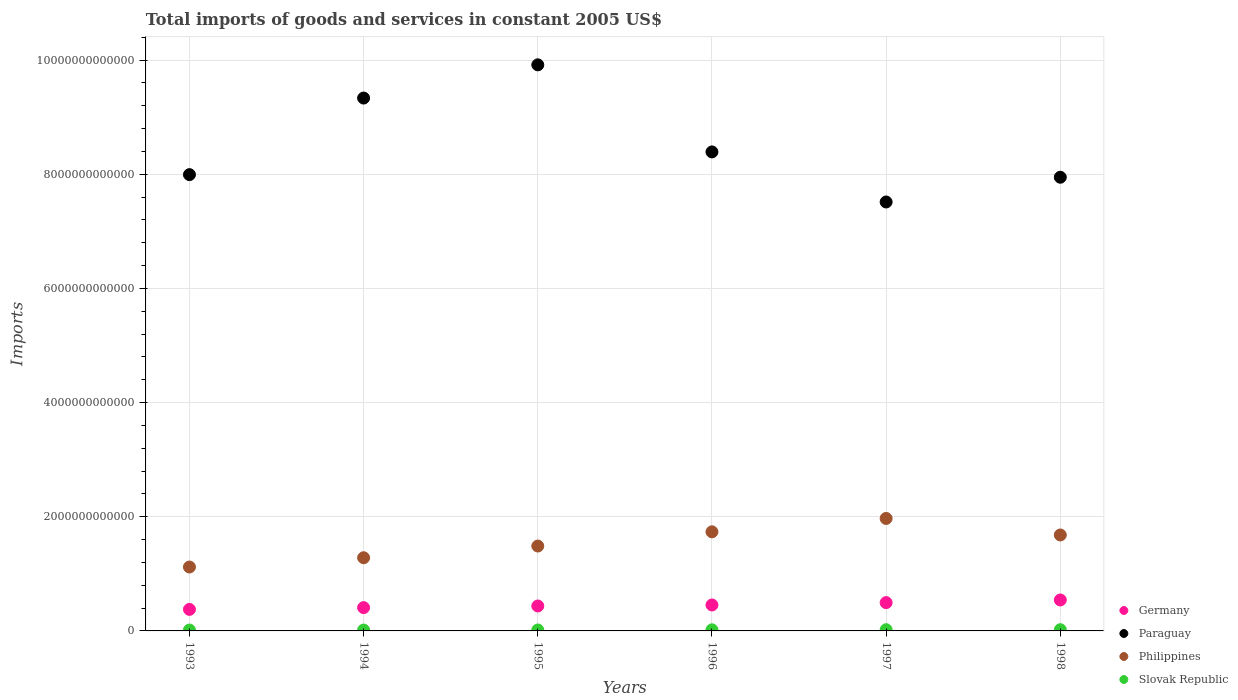How many different coloured dotlines are there?
Offer a terse response. 4. What is the total imports of goods and services in Paraguay in 1994?
Provide a succinct answer. 9.33e+12. Across all years, what is the maximum total imports of goods and services in Philippines?
Give a very brief answer. 1.97e+12. Across all years, what is the minimum total imports of goods and services in Slovak Republic?
Your answer should be compact. 1.49e+1. In which year was the total imports of goods and services in Slovak Republic minimum?
Make the answer very short. 1994. What is the total total imports of goods and services in Philippines in the graph?
Keep it short and to the point. 9.27e+12. What is the difference between the total imports of goods and services in Slovak Republic in 1996 and that in 1998?
Make the answer very short. -1.74e+09. What is the difference between the total imports of goods and services in Paraguay in 1993 and the total imports of goods and services in Slovak Republic in 1997?
Your answer should be compact. 7.97e+12. What is the average total imports of goods and services in Paraguay per year?
Your response must be concise. 8.52e+12. In the year 1995, what is the difference between the total imports of goods and services in Philippines and total imports of goods and services in Paraguay?
Give a very brief answer. -8.43e+12. In how many years, is the total imports of goods and services in Slovak Republic greater than 800000000000 US$?
Give a very brief answer. 0. What is the ratio of the total imports of goods and services in Germany in 1996 to that in 1998?
Ensure brevity in your answer.  0.84. Is the difference between the total imports of goods and services in Philippines in 1995 and 1997 greater than the difference between the total imports of goods and services in Paraguay in 1995 and 1997?
Keep it short and to the point. No. What is the difference between the highest and the second highest total imports of goods and services in Slovak Republic?
Your answer should be compact. 2.36e+08. What is the difference between the highest and the lowest total imports of goods and services in Slovak Republic?
Offer a terse response. 6.63e+09. Is it the case that in every year, the sum of the total imports of goods and services in Germany and total imports of goods and services in Slovak Republic  is greater than the total imports of goods and services in Philippines?
Make the answer very short. No. What is the difference between two consecutive major ticks on the Y-axis?
Your answer should be compact. 2.00e+12. Does the graph contain any zero values?
Make the answer very short. No. Does the graph contain grids?
Give a very brief answer. Yes. Where does the legend appear in the graph?
Provide a succinct answer. Bottom right. What is the title of the graph?
Make the answer very short. Total imports of goods and services in constant 2005 US$. What is the label or title of the X-axis?
Offer a terse response. Years. What is the label or title of the Y-axis?
Offer a terse response. Imports. What is the Imports of Germany in 1993?
Provide a short and direct response. 3.77e+11. What is the Imports of Paraguay in 1993?
Make the answer very short. 7.99e+12. What is the Imports of Philippines in 1993?
Your answer should be very brief. 1.12e+12. What is the Imports of Slovak Republic in 1993?
Your answer should be compact. 1.56e+1. What is the Imports in Germany in 1994?
Make the answer very short. 4.08e+11. What is the Imports in Paraguay in 1994?
Provide a succinct answer. 9.33e+12. What is the Imports in Philippines in 1994?
Provide a succinct answer. 1.28e+12. What is the Imports in Slovak Republic in 1994?
Provide a short and direct response. 1.49e+1. What is the Imports in Germany in 1995?
Provide a short and direct response. 4.37e+11. What is the Imports of Paraguay in 1995?
Offer a terse response. 9.92e+12. What is the Imports in Philippines in 1995?
Your answer should be very brief. 1.49e+12. What is the Imports of Slovak Republic in 1995?
Give a very brief answer. 1.66e+1. What is the Imports of Germany in 1996?
Keep it short and to the point. 4.54e+11. What is the Imports in Paraguay in 1996?
Your answer should be compact. 8.39e+12. What is the Imports in Philippines in 1996?
Provide a short and direct response. 1.74e+12. What is the Imports of Slovak Republic in 1996?
Your answer should be compact. 1.95e+1. What is the Imports in Germany in 1997?
Your answer should be compact. 4.96e+11. What is the Imports of Paraguay in 1997?
Your response must be concise. 7.51e+12. What is the Imports in Philippines in 1997?
Keep it short and to the point. 1.97e+12. What is the Imports of Slovak Republic in 1997?
Make the answer very short. 2.15e+1. What is the Imports in Germany in 1998?
Offer a very short reply. 5.42e+11. What is the Imports of Paraguay in 1998?
Your answer should be very brief. 7.95e+12. What is the Imports in Philippines in 1998?
Your answer should be compact. 1.68e+12. What is the Imports of Slovak Republic in 1998?
Give a very brief answer. 2.13e+1. Across all years, what is the maximum Imports in Germany?
Offer a terse response. 5.42e+11. Across all years, what is the maximum Imports of Paraguay?
Keep it short and to the point. 9.92e+12. Across all years, what is the maximum Imports in Philippines?
Provide a succinct answer. 1.97e+12. Across all years, what is the maximum Imports in Slovak Republic?
Your response must be concise. 2.15e+1. Across all years, what is the minimum Imports in Germany?
Give a very brief answer. 3.77e+11. Across all years, what is the minimum Imports of Paraguay?
Keep it short and to the point. 7.51e+12. Across all years, what is the minimum Imports in Philippines?
Ensure brevity in your answer.  1.12e+12. Across all years, what is the minimum Imports of Slovak Republic?
Your response must be concise. 1.49e+1. What is the total Imports in Germany in the graph?
Make the answer very short. 2.71e+12. What is the total Imports in Paraguay in the graph?
Your response must be concise. 5.11e+13. What is the total Imports in Philippines in the graph?
Provide a short and direct response. 9.27e+12. What is the total Imports of Slovak Republic in the graph?
Your answer should be compact. 1.09e+11. What is the difference between the Imports in Germany in 1993 and that in 1994?
Ensure brevity in your answer.  -3.10e+1. What is the difference between the Imports of Paraguay in 1993 and that in 1994?
Offer a terse response. -1.34e+12. What is the difference between the Imports of Philippines in 1993 and that in 1994?
Your answer should be very brief. -1.62e+11. What is the difference between the Imports in Slovak Republic in 1993 and that in 1994?
Ensure brevity in your answer.  7.39e+08. What is the difference between the Imports in Germany in 1993 and that in 1995?
Your answer should be compact. -5.98e+1. What is the difference between the Imports in Paraguay in 1993 and that in 1995?
Offer a very short reply. -1.92e+12. What is the difference between the Imports in Philippines in 1993 and that in 1995?
Ensure brevity in your answer.  -3.68e+11. What is the difference between the Imports of Slovak Republic in 1993 and that in 1995?
Provide a short and direct response. -9.92e+08. What is the difference between the Imports in Germany in 1993 and that in 1996?
Offer a very short reply. -7.74e+1. What is the difference between the Imports of Paraguay in 1993 and that in 1996?
Provide a short and direct response. -3.98e+11. What is the difference between the Imports of Philippines in 1993 and that in 1996?
Your answer should be compact. -6.17e+11. What is the difference between the Imports of Slovak Republic in 1993 and that in 1996?
Offer a very short reply. -3.91e+09. What is the difference between the Imports of Germany in 1993 and that in 1997?
Provide a succinct answer. -1.19e+11. What is the difference between the Imports in Paraguay in 1993 and that in 1997?
Your answer should be compact. 4.79e+11. What is the difference between the Imports in Philippines in 1993 and that in 1997?
Make the answer very short. -8.51e+11. What is the difference between the Imports in Slovak Republic in 1993 and that in 1997?
Your answer should be compact. -5.89e+09. What is the difference between the Imports in Germany in 1993 and that in 1998?
Your answer should be compact. -1.65e+11. What is the difference between the Imports of Paraguay in 1993 and that in 1998?
Your answer should be very brief. 4.57e+1. What is the difference between the Imports in Philippines in 1993 and that in 1998?
Ensure brevity in your answer.  -5.61e+11. What is the difference between the Imports in Slovak Republic in 1993 and that in 1998?
Your response must be concise. -5.65e+09. What is the difference between the Imports of Germany in 1994 and that in 1995?
Ensure brevity in your answer.  -2.89e+1. What is the difference between the Imports of Paraguay in 1994 and that in 1995?
Your response must be concise. -5.82e+11. What is the difference between the Imports of Philippines in 1994 and that in 1995?
Your answer should be compact. -2.05e+11. What is the difference between the Imports of Slovak Republic in 1994 and that in 1995?
Your answer should be compact. -1.73e+09. What is the difference between the Imports of Germany in 1994 and that in 1996?
Keep it short and to the point. -4.65e+1. What is the difference between the Imports in Paraguay in 1994 and that in 1996?
Make the answer very short. 9.44e+11. What is the difference between the Imports of Philippines in 1994 and that in 1996?
Your response must be concise. -4.54e+11. What is the difference between the Imports of Slovak Republic in 1994 and that in 1996?
Offer a terse response. -4.65e+09. What is the difference between the Imports in Germany in 1994 and that in 1997?
Your answer should be compact. -8.78e+1. What is the difference between the Imports in Paraguay in 1994 and that in 1997?
Your answer should be compact. 1.82e+12. What is the difference between the Imports of Philippines in 1994 and that in 1997?
Make the answer very short. -6.88e+11. What is the difference between the Imports of Slovak Republic in 1994 and that in 1997?
Keep it short and to the point. -6.63e+09. What is the difference between the Imports of Germany in 1994 and that in 1998?
Provide a succinct answer. -1.34e+11. What is the difference between the Imports in Paraguay in 1994 and that in 1998?
Give a very brief answer. 1.39e+12. What is the difference between the Imports in Philippines in 1994 and that in 1998?
Provide a succinct answer. -3.99e+11. What is the difference between the Imports of Slovak Republic in 1994 and that in 1998?
Provide a succinct answer. -6.39e+09. What is the difference between the Imports in Germany in 1995 and that in 1996?
Your response must be concise. -1.76e+1. What is the difference between the Imports in Paraguay in 1995 and that in 1996?
Your answer should be compact. 1.53e+12. What is the difference between the Imports in Philippines in 1995 and that in 1996?
Provide a succinct answer. -2.49e+11. What is the difference between the Imports in Slovak Republic in 1995 and that in 1996?
Your answer should be very brief. -2.92e+09. What is the difference between the Imports in Germany in 1995 and that in 1997?
Your answer should be very brief. -5.89e+1. What is the difference between the Imports in Paraguay in 1995 and that in 1997?
Offer a terse response. 2.40e+12. What is the difference between the Imports of Philippines in 1995 and that in 1997?
Give a very brief answer. -4.83e+11. What is the difference between the Imports of Slovak Republic in 1995 and that in 1997?
Provide a short and direct response. -4.90e+09. What is the difference between the Imports in Germany in 1995 and that in 1998?
Keep it short and to the point. -1.05e+11. What is the difference between the Imports of Paraguay in 1995 and that in 1998?
Provide a succinct answer. 1.97e+12. What is the difference between the Imports of Philippines in 1995 and that in 1998?
Keep it short and to the point. -1.94e+11. What is the difference between the Imports of Slovak Republic in 1995 and that in 1998?
Your response must be concise. -4.66e+09. What is the difference between the Imports in Germany in 1996 and that in 1997?
Make the answer very short. -4.13e+1. What is the difference between the Imports of Paraguay in 1996 and that in 1997?
Offer a terse response. 8.77e+11. What is the difference between the Imports in Philippines in 1996 and that in 1997?
Provide a short and direct response. -2.34e+11. What is the difference between the Imports of Slovak Republic in 1996 and that in 1997?
Your answer should be very brief. -1.98e+09. What is the difference between the Imports in Germany in 1996 and that in 1998?
Ensure brevity in your answer.  -8.78e+1. What is the difference between the Imports of Paraguay in 1996 and that in 1998?
Ensure brevity in your answer.  4.44e+11. What is the difference between the Imports in Philippines in 1996 and that in 1998?
Offer a terse response. 5.54e+1. What is the difference between the Imports in Slovak Republic in 1996 and that in 1998?
Your answer should be compact. -1.74e+09. What is the difference between the Imports in Germany in 1997 and that in 1998?
Make the answer very short. -4.65e+1. What is the difference between the Imports of Paraguay in 1997 and that in 1998?
Offer a very short reply. -4.33e+11. What is the difference between the Imports in Philippines in 1997 and that in 1998?
Provide a short and direct response. 2.90e+11. What is the difference between the Imports in Slovak Republic in 1997 and that in 1998?
Your answer should be very brief. 2.36e+08. What is the difference between the Imports in Germany in 1993 and the Imports in Paraguay in 1994?
Ensure brevity in your answer.  -8.96e+12. What is the difference between the Imports in Germany in 1993 and the Imports in Philippines in 1994?
Offer a very short reply. -9.05e+11. What is the difference between the Imports in Germany in 1993 and the Imports in Slovak Republic in 1994?
Ensure brevity in your answer.  3.62e+11. What is the difference between the Imports of Paraguay in 1993 and the Imports of Philippines in 1994?
Your response must be concise. 6.71e+12. What is the difference between the Imports in Paraguay in 1993 and the Imports in Slovak Republic in 1994?
Provide a short and direct response. 7.98e+12. What is the difference between the Imports in Philippines in 1993 and the Imports in Slovak Republic in 1994?
Make the answer very short. 1.10e+12. What is the difference between the Imports of Germany in 1993 and the Imports of Paraguay in 1995?
Give a very brief answer. -9.54e+12. What is the difference between the Imports in Germany in 1993 and the Imports in Philippines in 1995?
Offer a terse response. -1.11e+12. What is the difference between the Imports in Germany in 1993 and the Imports in Slovak Republic in 1995?
Your answer should be compact. 3.60e+11. What is the difference between the Imports in Paraguay in 1993 and the Imports in Philippines in 1995?
Your response must be concise. 6.51e+12. What is the difference between the Imports in Paraguay in 1993 and the Imports in Slovak Republic in 1995?
Give a very brief answer. 7.98e+12. What is the difference between the Imports in Philippines in 1993 and the Imports in Slovak Republic in 1995?
Give a very brief answer. 1.10e+12. What is the difference between the Imports of Germany in 1993 and the Imports of Paraguay in 1996?
Offer a very short reply. -8.01e+12. What is the difference between the Imports of Germany in 1993 and the Imports of Philippines in 1996?
Provide a short and direct response. -1.36e+12. What is the difference between the Imports of Germany in 1993 and the Imports of Slovak Republic in 1996?
Give a very brief answer. 3.58e+11. What is the difference between the Imports in Paraguay in 1993 and the Imports in Philippines in 1996?
Make the answer very short. 6.26e+12. What is the difference between the Imports in Paraguay in 1993 and the Imports in Slovak Republic in 1996?
Offer a terse response. 7.97e+12. What is the difference between the Imports in Philippines in 1993 and the Imports in Slovak Republic in 1996?
Keep it short and to the point. 1.10e+12. What is the difference between the Imports in Germany in 1993 and the Imports in Paraguay in 1997?
Offer a terse response. -7.14e+12. What is the difference between the Imports of Germany in 1993 and the Imports of Philippines in 1997?
Offer a very short reply. -1.59e+12. What is the difference between the Imports of Germany in 1993 and the Imports of Slovak Republic in 1997?
Provide a short and direct response. 3.56e+11. What is the difference between the Imports of Paraguay in 1993 and the Imports of Philippines in 1997?
Ensure brevity in your answer.  6.02e+12. What is the difference between the Imports in Paraguay in 1993 and the Imports in Slovak Republic in 1997?
Your answer should be very brief. 7.97e+12. What is the difference between the Imports of Philippines in 1993 and the Imports of Slovak Republic in 1997?
Offer a terse response. 1.10e+12. What is the difference between the Imports in Germany in 1993 and the Imports in Paraguay in 1998?
Your response must be concise. -7.57e+12. What is the difference between the Imports in Germany in 1993 and the Imports in Philippines in 1998?
Keep it short and to the point. -1.30e+12. What is the difference between the Imports of Germany in 1993 and the Imports of Slovak Republic in 1998?
Keep it short and to the point. 3.56e+11. What is the difference between the Imports in Paraguay in 1993 and the Imports in Philippines in 1998?
Offer a very short reply. 6.31e+12. What is the difference between the Imports of Paraguay in 1993 and the Imports of Slovak Republic in 1998?
Your response must be concise. 7.97e+12. What is the difference between the Imports in Philippines in 1993 and the Imports in Slovak Republic in 1998?
Keep it short and to the point. 1.10e+12. What is the difference between the Imports of Germany in 1994 and the Imports of Paraguay in 1995?
Keep it short and to the point. -9.51e+12. What is the difference between the Imports in Germany in 1994 and the Imports in Philippines in 1995?
Make the answer very short. -1.08e+12. What is the difference between the Imports of Germany in 1994 and the Imports of Slovak Republic in 1995?
Ensure brevity in your answer.  3.91e+11. What is the difference between the Imports of Paraguay in 1994 and the Imports of Philippines in 1995?
Offer a very short reply. 7.85e+12. What is the difference between the Imports of Paraguay in 1994 and the Imports of Slovak Republic in 1995?
Make the answer very short. 9.32e+12. What is the difference between the Imports of Philippines in 1994 and the Imports of Slovak Republic in 1995?
Your answer should be compact. 1.27e+12. What is the difference between the Imports in Germany in 1994 and the Imports in Paraguay in 1996?
Offer a terse response. -7.98e+12. What is the difference between the Imports of Germany in 1994 and the Imports of Philippines in 1996?
Ensure brevity in your answer.  -1.33e+12. What is the difference between the Imports in Germany in 1994 and the Imports in Slovak Republic in 1996?
Provide a short and direct response. 3.88e+11. What is the difference between the Imports in Paraguay in 1994 and the Imports in Philippines in 1996?
Keep it short and to the point. 7.60e+12. What is the difference between the Imports in Paraguay in 1994 and the Imports in Slovak Republic in 1996?
Provide a short and direct response. 9.31e+12. What is the difference between the Imports in Philippines in 1994 and the Imports in Slovak Republic in 1996?
Offer a terse response. 1.26e+12. What is the difference between the Imports in Germany in 1994 and the Imports in Paraguay in 1997?
Keep it short and to the point. -7.11e+12. What is the difference between the Imports in Germany in 1994 and the Imports in Philippines in 1997?
Give a very brief answer. -1.56e+12. What is the difference between the Imports of Germany in 1994 and the Imports of Slovak Republic in 1997?
Offer a terse response. 3.87e+11. What is the difference between the Imports of Paraguay in 1994 and the Imports of Philippines in 1997?
Your response must be concise. 7.36e+12. What is the difference between the Imports in Paraguay in 1994 and the Imports in Slovak Republic in 1997?
Keep it short and to the point. 9.31e+12. What is the difference between the Imports of Philippines in 1994 and the Imports of Slovak Republic in 1997?
Give a very brief answer. 1.26e+12. What is the difference between the Imports in Germany in 1994 and the Imports in Paraguay in 1998?
Ensure brevity in your answer.  -7.54e+12. What is the difference between the Imports of Germany in 1994 and the Imports of Philippines in 1998?
Ensure brevity in your answer.  -1.27e+12. What is the difference between the Imports of Germany in 1994 and the Imports of Slovak Republic in 1998?
Keep it short and to the point. 3.87e+11. What is the difference between the Imports in Paraguay in 1994 and the Imports in Philippines in 1998?
Your answer should be compact. 7.65e+12. What is the difference between the Imports of Paraguay in 1994 and the Imports of Slovak Republic in 1998?
Offer a very short reply. 9.31e+12. What is the difference between the Imports in Philippines in 1994 and the Imports in Slovak Republic in 1998?
Keep it short and to the point. 1.26e+12. What is the difference between the Imports of Germany in 1995 and the Imports of Paraguay in 1996?
Your answer should be compact. -7.95e+12. What is the difference between the Imports of Germany in 1995 and the Imports of Philippines in 1996?
Your answer should be compact. -1.30e+12. What is the difference between the Imports of Germany in 1995 and the Imports of Slovak Republic in 1996?
Provide a short and direct response. 4.17e+11. What is the difference between the Imports in Paraguay in 1995 and the Imports in Philippines in 1996?
Offer a very short reply. 8.18e+12. What is the difference between the Imports in Paraguay in 1995 and the Imports in Slovak Republic in 1996?
Your answer should be compact. 9.90e+12. What is the difference between the Imports in Philippines in 1995 and the Imports in Slovak Republic in 1996?
Your answer should be compact. 1.47e+12. What is the difference between the Imports of Germany in 1995 and the Imports of Paraguay in 1997?
Make the answer very short. -7.08e+12. What is the difference between the Imports of Germany in 1995 and the Imports of Philippines in 1997?
Provide a succinct answer. -1.53e+12. What is the difference between the Imports in Germany in 1995 and the Imports in Slovak Republic in 1997?
Offer a very short reply. 4.15e+11. What is the difference between the Imports of Paraguay in 1995 and the Imports of Philippines in 1997?
Keep it short and to the point. 7.95e+12. What is the difference between the Imports of Paraguay in 1995 and the Imports of Slovak Republic in 1997?
Your answer should be very brief. 9.89e+12. What is the difference between the Imports in Philippines in 1995 and the Imports in Slovak Republic in 1997?
Keep it short and to the point. 1.47e+12. What is the difference between the Imports in Germany in 1995 and the Imports in Paraguay in 1998?
Offer a very short reply. -7.51e+12. What is the difference between the Imports in Germany in 1995 and the Imports in Philippines in 1998?
Provide a succinct answer. -1.24e+12. What is the difference between the Imports in Germany in 1995 and the Imports in Slovak Republic in 1998?
Your response must be concise. 4.16e+11. What is the difference between the Imports in Paraguay in 1995 and the Imports in Philippines in 1998?
Your answer should be very brief. 8.24e+12. What is the difference between the Imports in Paraguay in 1995 and the Imports in Slovak Republic in 1998?
Your answer should be very brief. 9.89e+12. What is the difference between the Imports in Philippines in 1995 and the Imports in Slovak Republic in 1998?
Ensure brevity in your answer.  1.47e+12. What is the difference between the Imports in Germany in 1996 and the Imports in Paraguay in 1997?
Provide a short and direct response. -7.06e+12. What is the difference between the Imports in Germany in 1996 and the Imports in Philippines in 1997?
Offer a very short reply. -1.52e+12. What is the difference between the Imports of Germany in 1996 and the Imports of Slovak Republic in 1997?
Provide a short and direct response. 4.33e+11. What is the difference between the Imports of Paraguay in 1996 and the Imports of Philippines in 1997?
Your answer should be very brief. 6.42e+12. What is the difference between the Imports of Paraguay in 1996 and the Imports of Slovak Republic in 1997?
Your answer should be very brief. 8.37e+12. What is the difference between the Imports in Philippines in 1996 and the Imports in Slovak Republic in 1997?
Provide a short and direct response. 1.71e+12. What is the difference between the Imports of Germany in 1996 and the Imports of Paraguay in 1998?
Provide a short and direct response. -7.49e+12. What is the difference between the Imports of Germany in 1996 and the Imports of Philippines in 1998?
Offer a terse response. -1.23e+12. What is the difference between the Imports of Germany in 1996 and the Imports of Slovak Republic in 1998?
Provide a succinct answer. 4.33e+11. What is the difference between the Imports of Paraguay in 1996 and the Imports of Philippines in 1998?
Your answer should be very brief. 6.71e+12. What is the difference between the Imports of Paraguay in 1996 and the Imports of Slovak Republic in 1998?
Keep it short and to the point. 8.37e+12. What is the difference between the Imports in Philippines in 1996 and the Imports in Slovak Republic in 1998?
Keep it short and to the point. 1.71e+12. What is the difference between the Imports of Germany in 1997 and the Imports of Paraguay in 1998?
Offer a terse response. -7.45e+12. What is the difference between the Imports in Germany in 1997 and the Imports in Philippines in 1998?
Keep it short and to the point. -1.18e+12. What is the difference between the Imports of Germany in 1997 and the Imports of Slovak Republic in 1998?
Keep it short and to the point. 4.75e+11. What is the difference between the Imports in Paraguay in 1997 and the Imports in Philippines in 1998?
Your answer should be very brief. 5.83e+12. What is the difference between the Imports in Paraguay in 1997 and the Imports in Slovak Republic in 1998?
Provide a short and direct response. 7.49e+12. What is the difference between the Imports in Philippines in 1997 and the Imports in Slovak Republic in 1998?
Make the answer very short. 1.95e+12. What is the average Imports in Germany per year?
Keep it short and to the point. 4.52e+11. What is the average Imports in Paraguay per year?
Offer a terse response. 8.52e+12. What is the average Imports of Philippines per year?
Keep it short and to the point. 1.55e+12. What is the average Imports of Slovak Republic per year?
Provide a short and direct response. 1.82e+1. In the year 1993, what is the difference between the Imports in Germany and Imports in Paraguay?
Offer a terse response. -7.62e+12. In the year 1993, what is the difference between the Imports in Germany and Imports in Philippines?
Offer a terse response. -7.42e+11. In the year 1993, what is the difference between the Imports of Germany and Imports of Slovak Republic?
Your answer should be compact. 3.61e+11. In the year 1993, what is the difference between the Imports of Paraguay and Imports of Philippines?
Provide a short and direct response. 6.87e+12. In the year 1993, what is the difference between the Imports of Paraguay and Imports of Slovak Republic?
Keep it short and to the point. 7.98e+12. In the year 1993, what is the difference between the Imports of Philippines and Imports of Slovak Republic?
Keep it short and to the point. 1.10e+12. In the year 1994, what is the difference between the Imports in Germany and Imports in Paraguay?
Offer a very short reply. -8.93e+12. In the year 1994, what is the difference between the Imports of Germany and Imports of Philippines?
Keep it short and to the point. -8.74e+11. In the year 1994, what is the difference between the Imports in Germany and Imports in Slovak Republic?
Offer a terse response. 3.93e+11. In the year 1994, what is the difference between the Imports of Paraguay and Imports of Philippines?
Your response must be concise. 8.05e+12. In the year 1994, what is the difference between the Imports in Paraguay and Imports in Slovak Republic?
Provide a succinct answer. 9.32e+12. In the year 1994, what is the difference between the Imports of Philippines and Imports of Slovak Republic?
Your answer should be compact. 1.27e+12. In the year 1995, what is the difference between the Imports in Germany and Imports in Paraguay?
Your answer should be very brief. -9.48e+12. In the year 1995, what is the difference between the Imports in Germany and Imports in Philippines?
Your answer should be very brief. -1.05e+12. In the year 1995, what is the difference between the Imports in Germany and Imports in Slovak Republic?
Keep it short and to the point. 4.20e+11. In the year 1995, what is the difference between the Imports in Paraguay and Imports in Philippines?
Offer a very short reply. 8.43e+12. In the year 1995, what is the difference between the Imports of Paraguay and Imports of Slovak Republic?
Offer a terse response. 9.90e+12. In the year 1995, what is the difference between the Imports of Philippines and Imports of Slovak Republic?
Make the answer very short. 1.47e+12. In the year 1996, what is the difference between the Imports of Germany and Imports of Paraguay?
Your answer should be very brief. -7.94e+12. In the year 1996, what is the difference between the Imports of Germany and Imports of Philippines?
Give a very brief answer. -1.28e+12. In the year 1996, what is the difference between the Imports in Germany and Imports in Slovak Republic?
Your answer should be compact. 4.35e+11. In the year 1996, what is the difference between the Imports of Paraguay and Imports of Philippines?
Your answer should be very brief. 6.65e+12. In the year 1996, what is the difference between the Imports in Paraguay and Imports in Slovak Republic?
Offer a terse response. 8.37e+12. In the year 1996, what is the difference between the Imports of Philippines and Imports of Slovak Republic?
Provide a succinct answer. 1.72e+12. In the year 1997, what is the difference between the Imports of Germany and Imports of Paraguay?
Ensure brevity in your answer.  -7.02e+12. In the year 1997, what is the difference between the Imports of Germany and Imports of Philippines?
Give a very brief answer. -1.47e+12. In the year 1997, what is the difference between the Imports in Germany and Imports in Slovak Republic?
Make the answer very short. 4.74e+11. In the year 1997, what is the difference between the Imports of Paraguay and Imports of Philippines?
Provide a succinct answer. 5.54e+12. In the year 1997, what is the difference between the Imports of Paraguay and Imports of Slovak Republic?
Your response must be concise. 7.49e+12. In the year 1997, what is the difference between the Imports of Philippines and Imports of Slovak Republic?
Provide a short and direct response. 1.95e+12. In the year 1998, what is the difference between the Imports in Germany and Imports in Paraguay?
Offer a terse response. -7.40e+12. In the year 1998, what is the difference between the Imports of Germany and Imports of Philippines?
Offer a terse response. -1.14e+12. In the year 1998, what is the difference between the Imports in Germany and Imports in Slovak Republic?
Give a very brief answer. 5.21e+11. In the year 1998, what is the difference between the Imports in Paraguay and Imports in Philippines?
Ensure brevity in your answer.  6.27e+12. In the year 1998, what is the difference between the Imports of Paraguay and Imports of Slovak Republic?
Provide a succinct answer. 7.93e+12. In the year 1998, what is the difference between the Imports in Philippines and Imports in Slovak Republic?
Provide a succinct answer. 1.66e+12. What is the ratio of the Imports in Germany in 1993 to that in 1994?
Your answer should be very brief. 0.92. What is the ratio of the Imports of Paraguay in 1993 to that in 1994?
Ensure brevity in your answer.  0.86. What is the ratio of the Imports in Philippines in 1993 to that in 1994?
Your response must be concise. 0.87. What is the ratio of the Imports of Slovak Republic in 1993 to that in 1994?
Your answer should be very brief. 1.05. What is the ratio of the Imports of Germany in 1993 to that in 1995?
Provide a succinct answer. 0.86. What is the ratio of the Imports in Paraguay in 1993 to that in 1995?
Offer a terse response. 0.81. What is the ratio of the Imports in Philippines in 1993 to that in 1995?
Provide a succinct answer. 0.75. What is the ratio of the Imports in Slovak Republic in 1993 to that in 1995?
Your response must be concise. 0.94. What is the ratio of the Imports of Germany in 1993 to that in 1996?
Your answer should be compact. 0.83. What is the ratio of the Imports in Paraguay in 1993 to that in 1996?
Give a very brief answer. 0.95. What is the ratio of the Imports of Philippines in 1993 to that in 1996?
Your answer should be very brief. 0.64. What is the ratio of the Imports of Slovak Republic in 1993 to that in 1996?
Offer a terse response. 0.8. What is the ratio of the Imports of Germany in 1993 to that in 1997?
Provide a short and direct response. 0.76. What is the ratio of the Imports of Paraguay in 1993 to that in 1997?
Your answer should be compact. 1.06. What is the ratio of the Imports of Philippines in 1993 to that in 1997?
Your answer should be compact. 0.57. What is the ratio of the Imports of Slovak Republic in 1993 to that in 1997?
Keep it short and to the point. 0.73. What is the ratio of the Imports in Germany in 1993 to that in 1998?
Make the answer very short. 0.7. What is the ratio of the Imports in Philippines in 1993 to that in 1998?
Your answer should be compact. 0.67. What is the ratio of the Imports in Slovak Republic in 1993 to that in 1998?
Keep it short and to the point. 0.73. What is the ratio of the Imports in Germany in 1994 to that in 1995?
Keep it short and to the point. 0.93. What is the ratio of the Imports in Paraguay in 1994 to that in 1995?
Give a very brief answer. 0.94. What is the ratio of the Imports of Philippines in 1994 to that in 1995?
Your answer should be very brief. 0.86. What is the ratio of the Imports in Slovak Republic in 1994 to that in 1995?
Provide a succinct answer. 0.9. What is the ratio of the Imports in Germany in 1994 to that in 1996?
Offer a very short reply. 0.9. What is the ratio of the Imports in Paraguay in 1994 to that in 1996?
Give a very brief answer. 1.11. What is the ratio of the Imports in Philippines in 1994 to that in 1996?
Provide a short and direct response. 0.74. What is the ratio of the Imports of Slovak Republic in 1994 to that in 1996?
Your answer should be compact. 0.76. What is the ratio of the Imports of Germany in 1994 to that in 1997?
Your response must be concise. 0.82. What is the ratio of the Imports of Paraguay in 1994 to that in 1997?
Ensure brevity in your answer.  1.24. What is the ratio of the Imports in Philippines in 1994 to that in 1997?
Your answer should be very brief. 0.65. What is the ratio of the Imports in Slovak Republic in 1994 to that in 1997?
Provide a short and direct response. 0.69. What is the ratio of the Imports in Germany in 1994 to that in 1998?
Provide a short and direct response. 0.75. What is the ratio of the Imports of Paraguay in 1994 to that in 1998?
Give a very brief answer. 1.17. What is the ratio of the Imports in Philippines in 1994 to that in 1998?
Provide a succinct answer. 0.76. What is the ratio of the Imports in Slovak Republic in 1994 to that in 1998?
Make the answer very short. 0.7. What is the ratio of the Imports of Germany in 1995 to that in 1996?
Your answer should be compact. 0.96. What is the ratio of the Imports of Paraguay in 1995 to that in 1996?
Make the answer very short. 1.18. What is the ratio of the Imports of Philippines in 1995 to that in 1996?
Offer a very short reply. 0.86. What is the ratio of the Imports in Slovak Republic in 1995 to that in 1996?
Make the answer very short. 0.85. What is the ratio of the Imports of Germany in 1995 to that in 1997?
Make the answer very short. 0.88. What is the ratio of the Imports of Paraguay in 1995 to that in 1997?
Make the answer very short. 1.32. What is the ratio of the Imports in Philippines in 1995 to that in 1997?
Your answer should be very brief. 0.75. What is the ratio of the Imports of Slovak Republic in 1995 to that in 1997?
Give a very brief answer. 0.77. What is the ratio of the Imports of Germany in 1995 to that in 1998?
Your response must be concise. 0.81. What is the ratio of the Imports of Paraguay in 1995 to that in 1998?
Provide a succinct answer. 1.25. What is the ratio of the Imports in Philippines in 1995 to that in 1998?
Your response must be concise. 0.88. What is the ratio of the Imports of Slovak Republic in 1995 to that in 1998?
Your response must be concise. 0.78. What is the ratio of the Imports in Paraguay in 1996 to that in 1997?
Your answer should be very brief. 1.12. What is the ratio of the Imports of Philippines in 1996 to that in 1997?
Give a very brief answer. 0.88. What is the ratio of the Imports of Slovak Republic in 1996 to that in 1997?
Your response must be concise. 0.91. What is the ratio of the Imports in Germany in 1996 to that in 1998?
Your response must be concise. 0.84. What is the ratio of the Imports of Paraguay in 1996 to that in 1998?
Ensure brevity in your answer.  1.06. What is the ratio of the Imports in Philippines in 1996 to that in 1998?
Your answer should be very brief. 1.03. What is the ratio of the Imports of Slovak Republic in 1996 to that in 1998?
Provide a short and direct response. 0.92. What is the ratio of the Imports in Germany in 1997 to that in 1998?
Your answer should be compact. 0.91. What is the ratio of the Imports of Paraguay in 1997 to that in 1998?
Your answer should be compact. 0.95. What is the ratio of the Imports in Philippines in 1997 to that in 1998?
Your response must be concise. 1.17. What is the ratio of the Imports of Slovak Republic in 1997 to that in 1998?
Your response must be concise. 1.01. What is the difference between the highest and the second highest Imports in Germany?
Give a very brief answer. 4.65e+1. What is the difference between the highest and the second highest Imports in Paraguay?
Provide a succinct answer. 5.82e+11. What is the difference between the highest and the second highest Imports in Philippines?
Provide a short and direct response. 2.34e+11. What is the difference between the highest and the second highest Imports of Slovak Republic?
Your answer should be very brief. 2.36e+08. What is the difference between the highest and the lowest Imports of Germany?
Provide a short and direct response. 1.65e+11. What is the difference between the highest and the lowest Imports of Paraguay?
Your response must be concise. 2.40e+12. What is the difference between the highest and the lowest Imports of Philippines?
Offer a very short reply. 8.51e+11. What is the difference between the highest and the lowest Imports in Slovak Republic?
Give a very brief answer. 6.63e+09. 